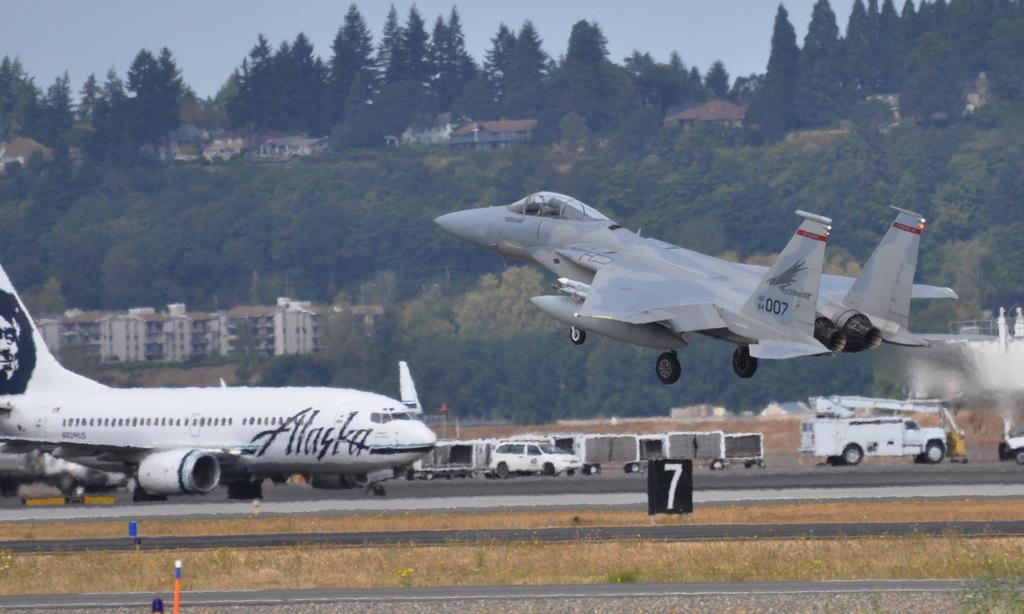What name is written on the white plane?
Make the answer very short. Alaska. What is the plane number?
Offer a terse response. 007. 